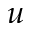Convert formula to latex. <formula><loc_0><loc_0><loc_500><loc_500>u</formula> 